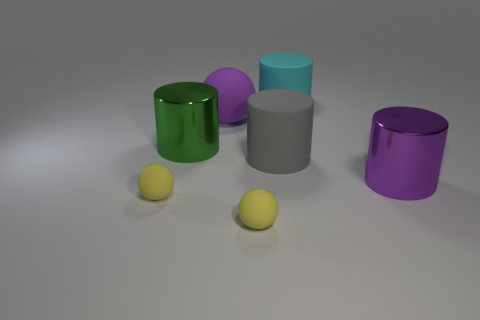Does the big green object have the same material as the sphere that is behind the purple metallic object?
Offer a terse response. No. What number of other things are the same material as the green thing?
Ensure brevity in your answer.  1. There is a big metal thing right of the large cyan cylinder; what shape is it?
Offer a terse response. Cylinder. Are the large purple thing left of the big purple cylinder and the purple thing that is in front of the gray object made of the same material?
Provide a succinct answer. No. Is there a gray thing that has the same shape as the green object?
Your answer should be compact. Yes. What number of things are objects that are left of the green metal cylinder or big gray matte objects?
Ensure brevity in your answer.  2. Are there more matte cylinders left of the green thing than green cylinders that are in front of the large purple matte thing?
Make the answer very short. No. What number of metallic things are either green cylinders or big red cylinders?
Your answer should be compact. 1. There is a big cylinder that is the same color as the big sphere; what is its material?
Provide a short and direct response. Metal. Is the number of large green objects that are in front of the large purple shiny cylinder less than the number of rubber cylinders in front of the large purple matte sphere?
Offer a terse response. Yes. 